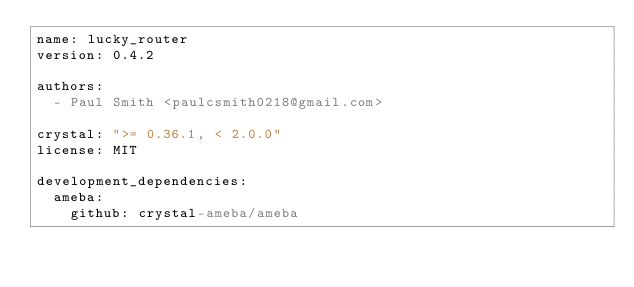<code> <loc_0><loc_0><loc_500><loc_500><_YAML_>name: lucky_router
version: 0.4.2

authors:
  - Paul Smith <paulcsmith0218@gmail.com>

crystal: ">= 0.36.1, < 2.0.0"
license: MIT

development_dependencies:
  ameba:
    github: crystal-ameba/ameba</code> 